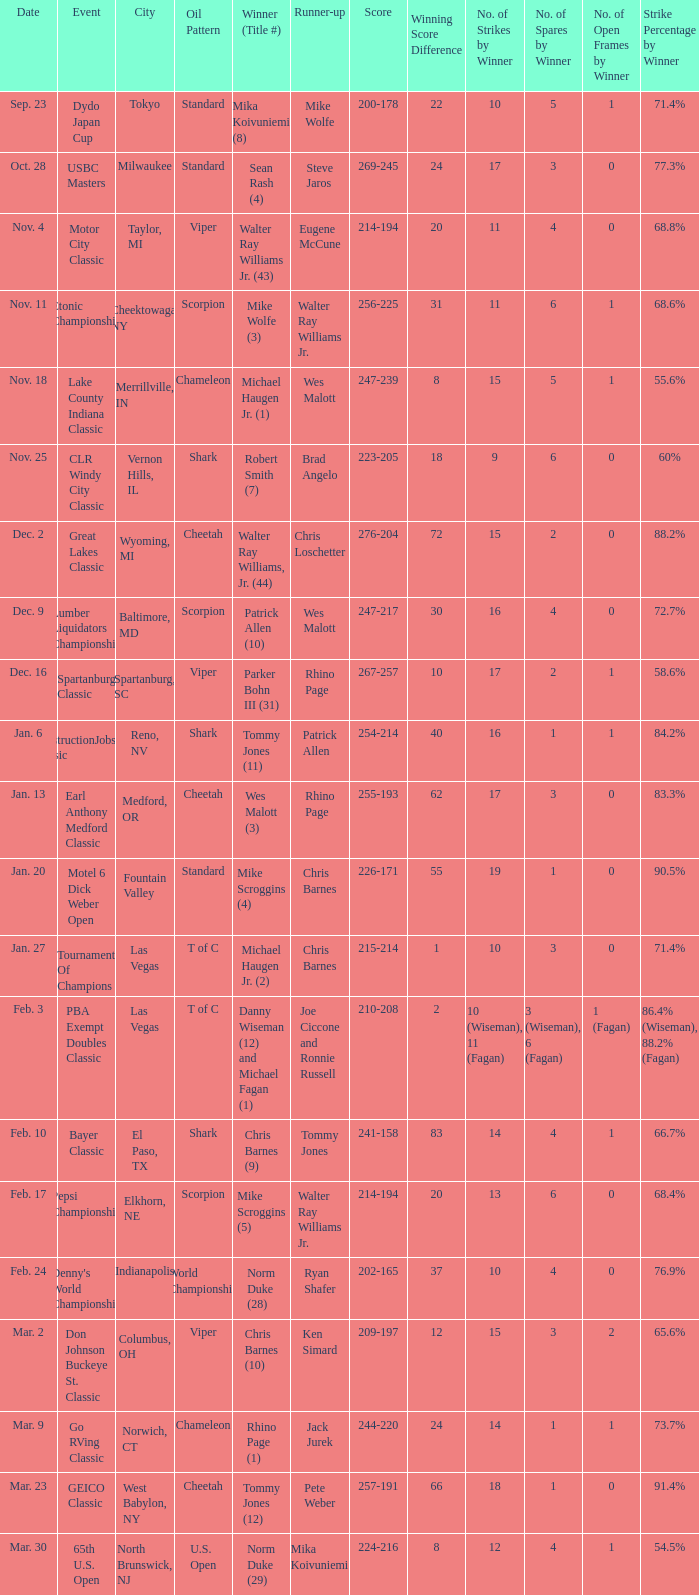Could you parse the entire table as a dict? {'header': ['Date', 'Event', 'City', 'Oil Pattern', 'Winner (Title #)', 'Runner-up', 'Score', 'Winning Score Difference', 'No. of Strikes by Winner', 'No. of Spares by Winner', 'No. of Open Frames by Winner', 'Strike Percentage by Winner'], 'rows': [['Sep. 23', 'Dydo Japan Cup', 'Tokyo', 'Standard', 'Mika Koivuniemi (8)', 'Mike Wolfe', '200-178', '22', '10', '5', '1', '71.4%'], ['Oct. 28', 'USBC Masters', 'Milwaukee', 'Standard', 'Sean Rash (4)', 'Steve Jaros', '269-245', '24', '17', '3', '0', '77.3%'], ['Nov. 4', 'Motor City Classic', 'Taylor, MI', 'Viper', 'Walter Ray Williams Jr. (43)', 'Eugene McCune', '214-194', '20', '11', '4', '0', '68.8%'], ['Nov. 11', 'Etonic Championship', 'Cheektowaga, NY', 'Scorpion', 'Mike Wolfe (3)', 'Walter Ray Williams Jr.', '256-225', '31', '11', '6', '1', '68.6%'], ['Nov. 18', 'Lake County Indiana Classic', 'Merrillville, IN', 'Chameleon', 'Michael Haugen Jr. (1)', 'Wes Malott', '247-239', '8', '15', '5', '1', '55.6%'], ['Nov. 25', 'CLR Windy City Classic', 'Vernon Hills, IL', 'Shark', 'Robert Smith (7)', 'Brad Angelo', '223-205', '18', '9', '6', '0', '60%'], ['Dec. 2', 'Great Lakes Classic', 'Wyoming, MI', 'Cheetah', 'Walter Ray Williams, Jr. (44)', 'Chris Loschetter', '276-204', '72', '15', '2', '0', '88.2%'], ['Dec. 9', 'Lumber Liquidators Championship', 'Baltimore, MD', 'Scorpion', 'Patrick Allen (10)', 'Wes Malott', '247-217', '30', '16', '4', '0', '72.7%'], ['Dec. 16', 'Spartanburg Classic', 'Spartanburg, SC', 'Viper', 'Parker Bohn III (31)', 'Rhino Page', '267-257', '10', '17', '2', '1', '58.6%'], ['Jan. 6', 'ConstructionJobs.com Classic', 'Reno, NV', 'Shark', 'Tommy Jones (11)', 'Patrick Allen', '254-214', '40', '16', '1', '1', '84.2%'], ['Jan. 13', 'Earl Anthony Medford Classic', 'Medford, OR', 'Cheetah', 'Wes Malott (3)', 'Rhino Page', '255-193', '62', '17', '3', '0', '83.3%'], ['Jan. 20', 'Motel 6 Dick Weber Open', 'Fountain Valley', 'Standard', 'Mike Scroggins (4)', 'Chris Barnes', '226-171', '55', '19', '1', '0', '90.5%'], ['Jan. 27', 'Tournament Of Champions', 'Las Vegas', 'T of C', 'Michael Haugen Jr. (2)', 'Chris Barnes', '215-214', '1', '10', '3', '0', '71.4%'], ['Feb. 3', 'PBA Exempt Doubles Classic', 'Las Vegas', 'T of C', 'Danny Wiseman (12) and Michael Fagan (1)', 'Joe Ciccone and Ronnie Russell', '210-208', '2', '10 (Wiseman), 11 (Fagan)', '3 (Wiseman), 6 (Fagan)', '1 (Fagan)', '86.4% (Wiseman), 88.2% (Fagan)'], ['Feb. 10', 'Bayer Classic', 'El Paso, TX', 'Shark', 'Chris Barnes (9)', 'Tommy Jones', '241-158', '83', '14', '4', '1', '66.7%'], ['Feb. 17', 'Pepsi Championship', 'Elkhorn, NE', 'Scorpion', 'Mike Scroggins (5)', 'Walter Ray Williams Jr.', '214-194', '20', '13', '6', '0', '68.4%'], ['Feb. 24', "Denny's World Championship", 'Indianapolis', 'World Championship', 'Norm Duke (28)', 'Ryan Shafer', '202-165', '37', '10', '4', '0', '76.9%'], ['Mar. 2', 'Don Johnson Buckeye St. Classic', 'Columbus, OH', 'Viper', 'Chris Barnes (10)', 'Ken Simard', '209-197', '12', '15', '3', '2', '65.6%'], ['Mar. 9', 'Go RVing Classic', 'Norwich, CT', 'Chameleon', 'Rhino Page (1)', 'Jack Jurek', '244-220', '24', '14', '1', '1', '73.7%'], ['Mar. 23', 'GEICO Classic', 'West Babylon, NY', 'Cheetah', 'Tommy Jones (12)', 'Pete Weber', '257-191', '66', '18', '1', '0', '91.4%'], ['Mar. 30', '65th U.S. Open', 'North Brunswick, NJ', 'U.S. Open', 'Norm Duke (29)', 'Mika Koivuniemi', '224-216', '8', '12', '4', '1', '54.5%']]} Name the Date which has a Oil Pattern of chameleon, and a Event of lake county indiana classic? Nov. 18. 